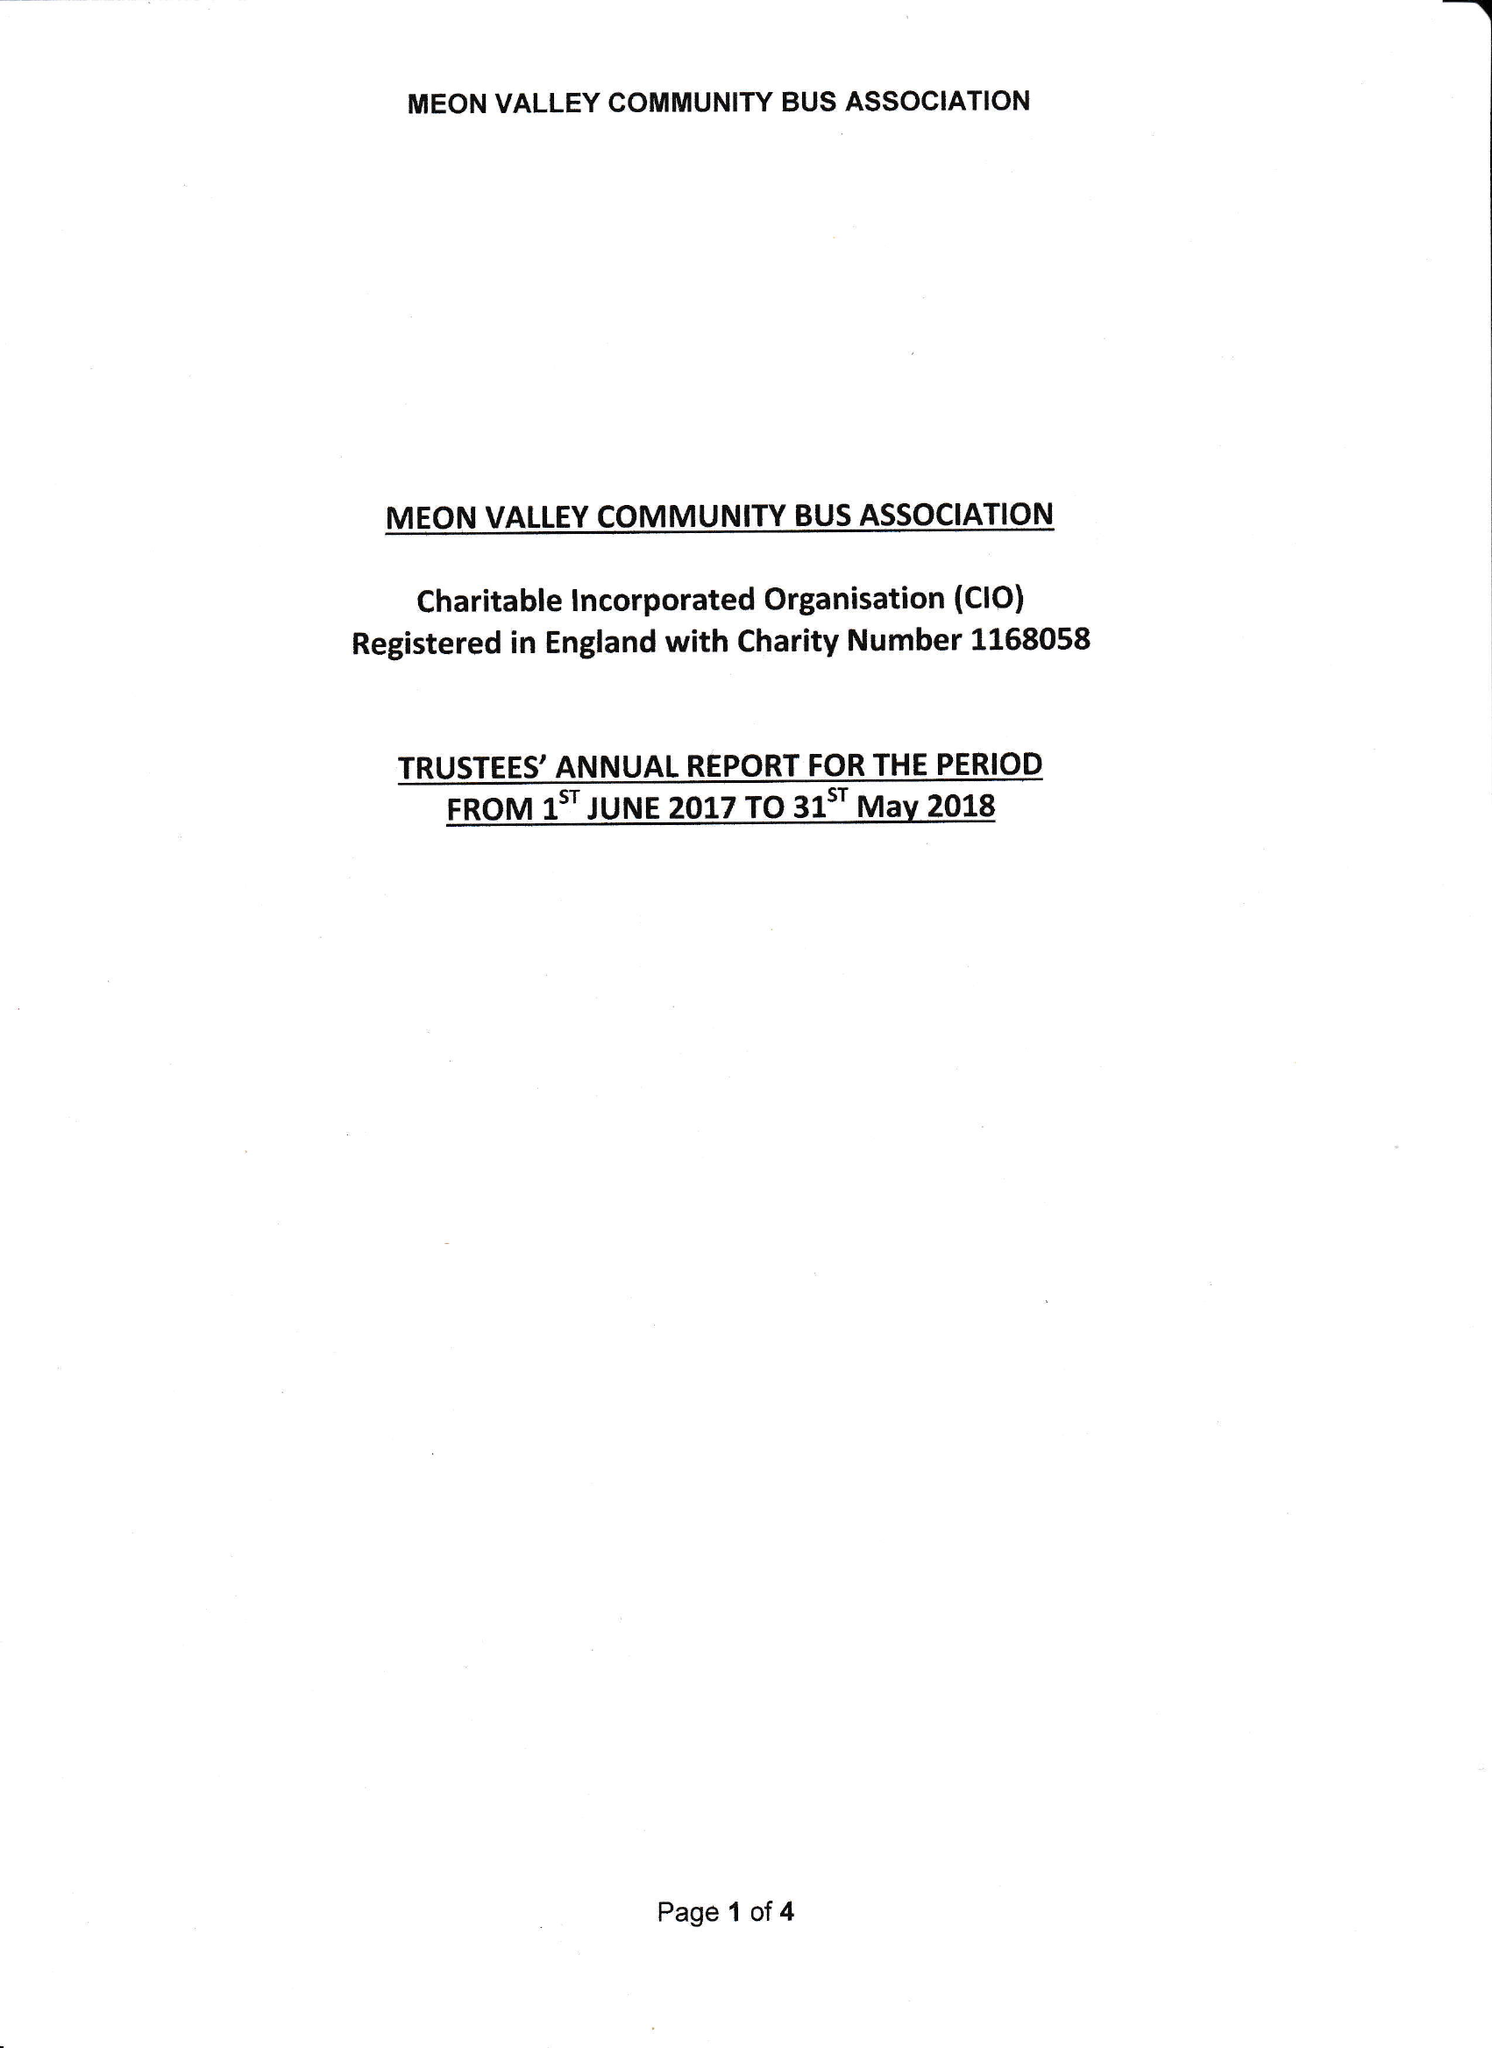What is the value for the address__post_town?
Answer the question using a single word or phrase. None 